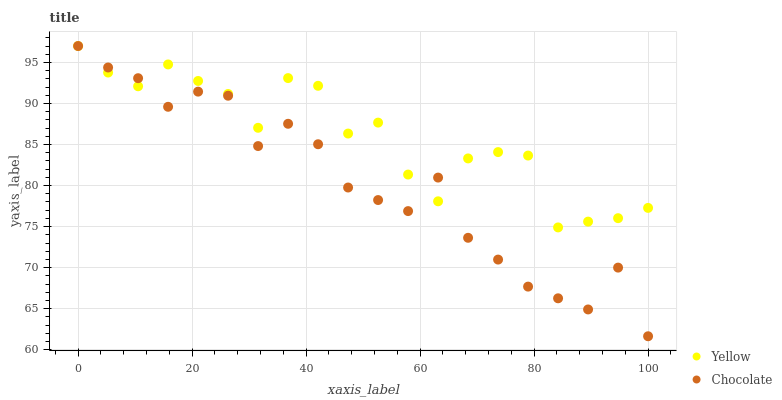Does Chocolate have the minimum area under the curve?
Answer yes or no. Yes. Does Yellow have the maximum area under the curve?
Answer yes or no. Yes. Does Chocolate have the maximum area under the curve?
Answer yes or no. No. Is Chocolate the smoothest?
Answer yes or no. Yes. Is Yellow the roughest?
Answer yes or no. Yes. Is Chocolate the roughest?
Answer yes or no. No. Does Chocolate have the lowest value?
Answer yes or no. Yes. Does Chocolate have the highest value?
Answer yes or no. Yes. Does Chocolate intersect Yellow?
Answer yes or no. Yes. Is Chocolate less than Yellow?
Answer yes or no. No. Is Chocolate greater than Yellow?
Answer yes or no. No. 